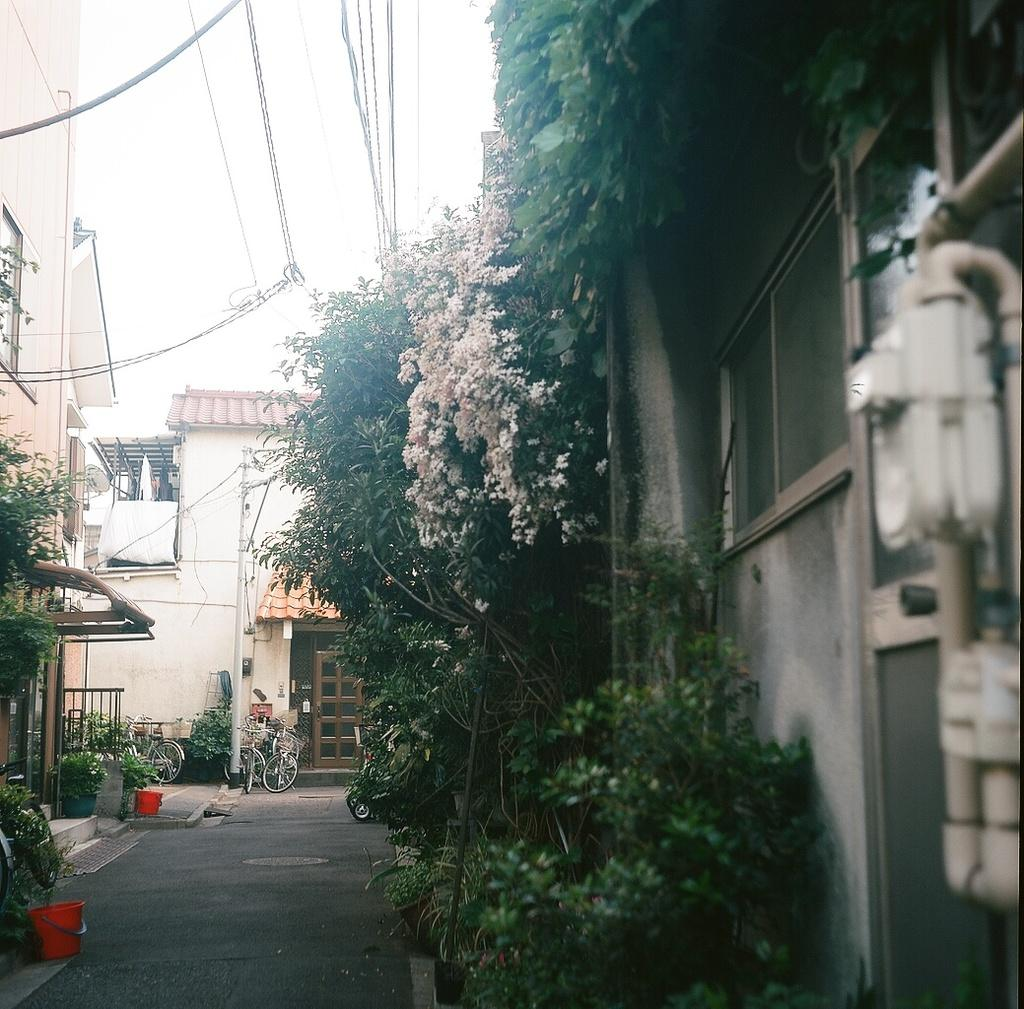What is the main feature of the image? There is a road in the image. What can be seen alongside the road? There are bicycles, trees, flowers, buildings, wires, and some objects in the image. What is visible in the background of the image? The sky is visible in the background of the image. What type of glass is being used to construct the buildings in the image? There is no information about the type of glass used in the construction of the buildings in the image. Can you see a sofa in the image? No, there is no sofa present in the image. 